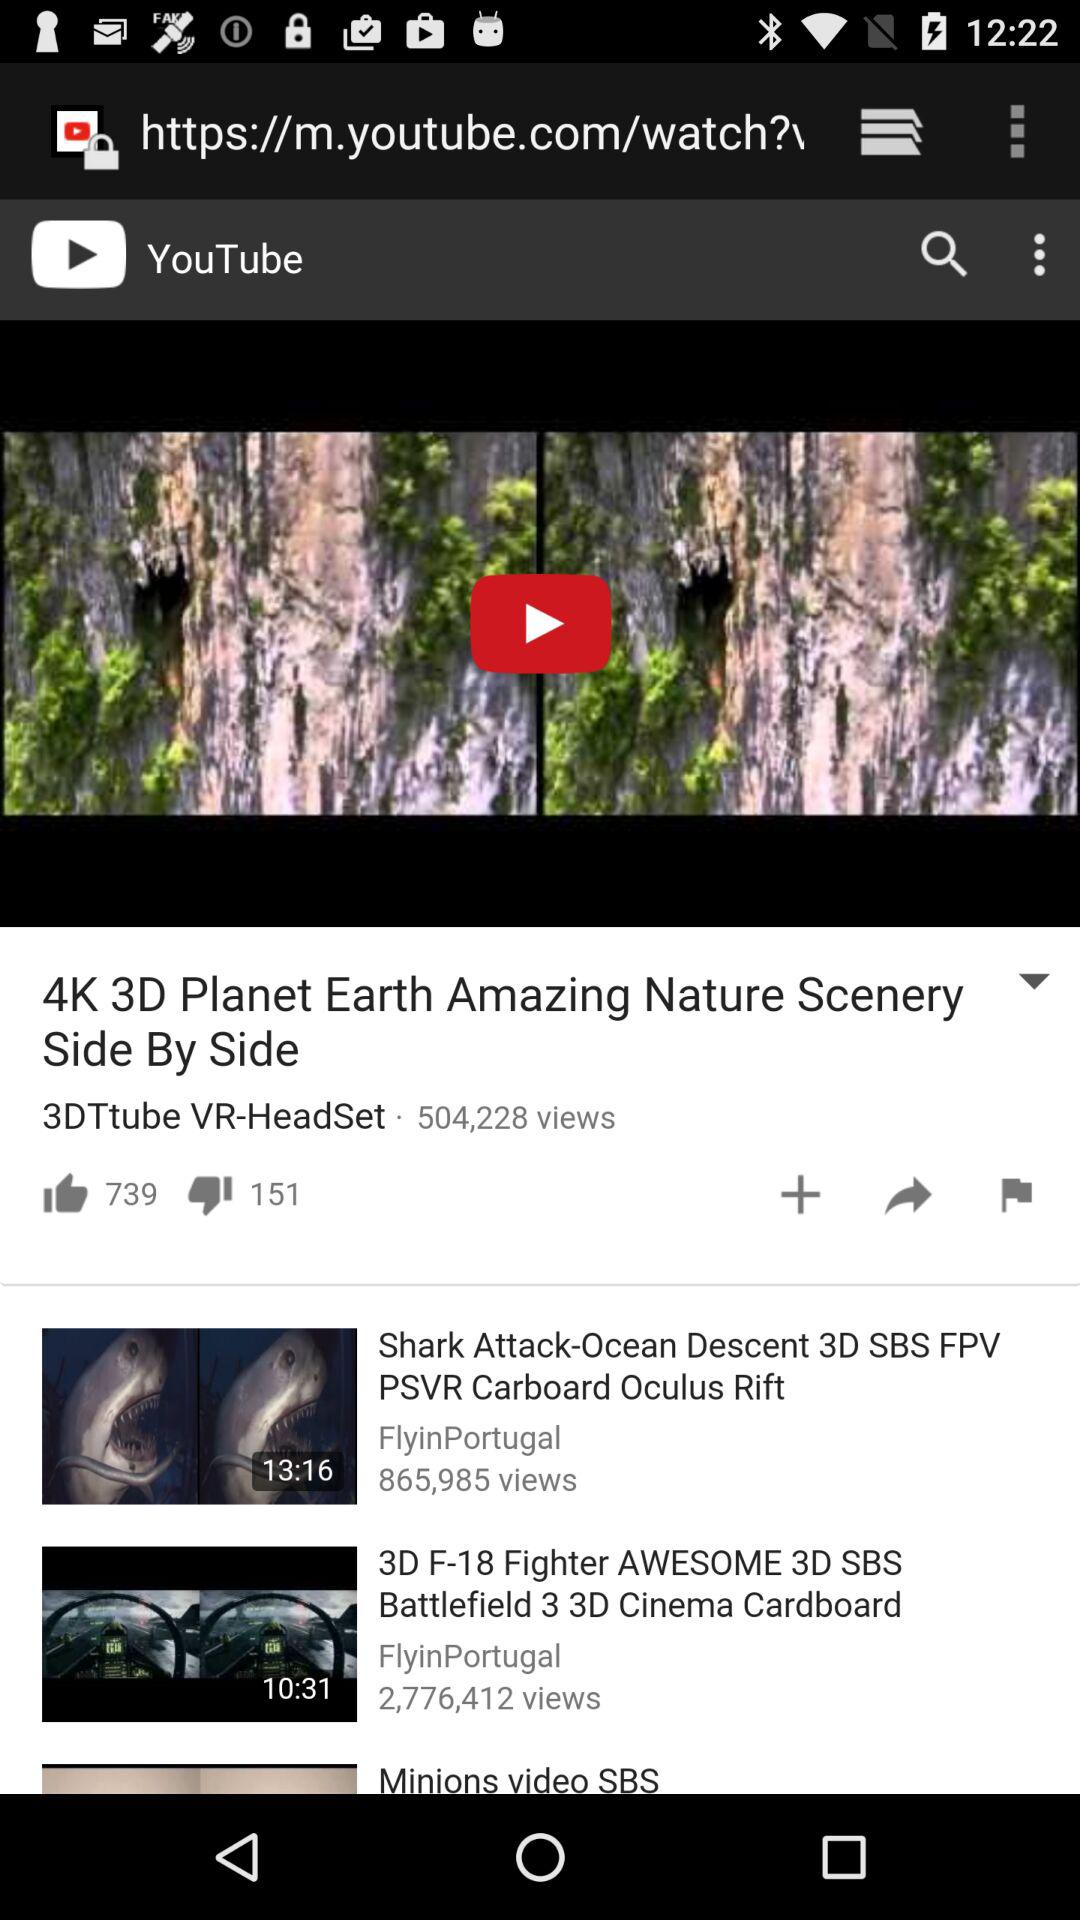How many views on the "Shark Attack-Ocean Descent 3D SBS FPV PSVR Carboard Oculus Rift" video? There is 865,985 views on the "Shark Attack-Ocean Descent 3D SBS FPV PSVR Carboard Oculus Rift". 